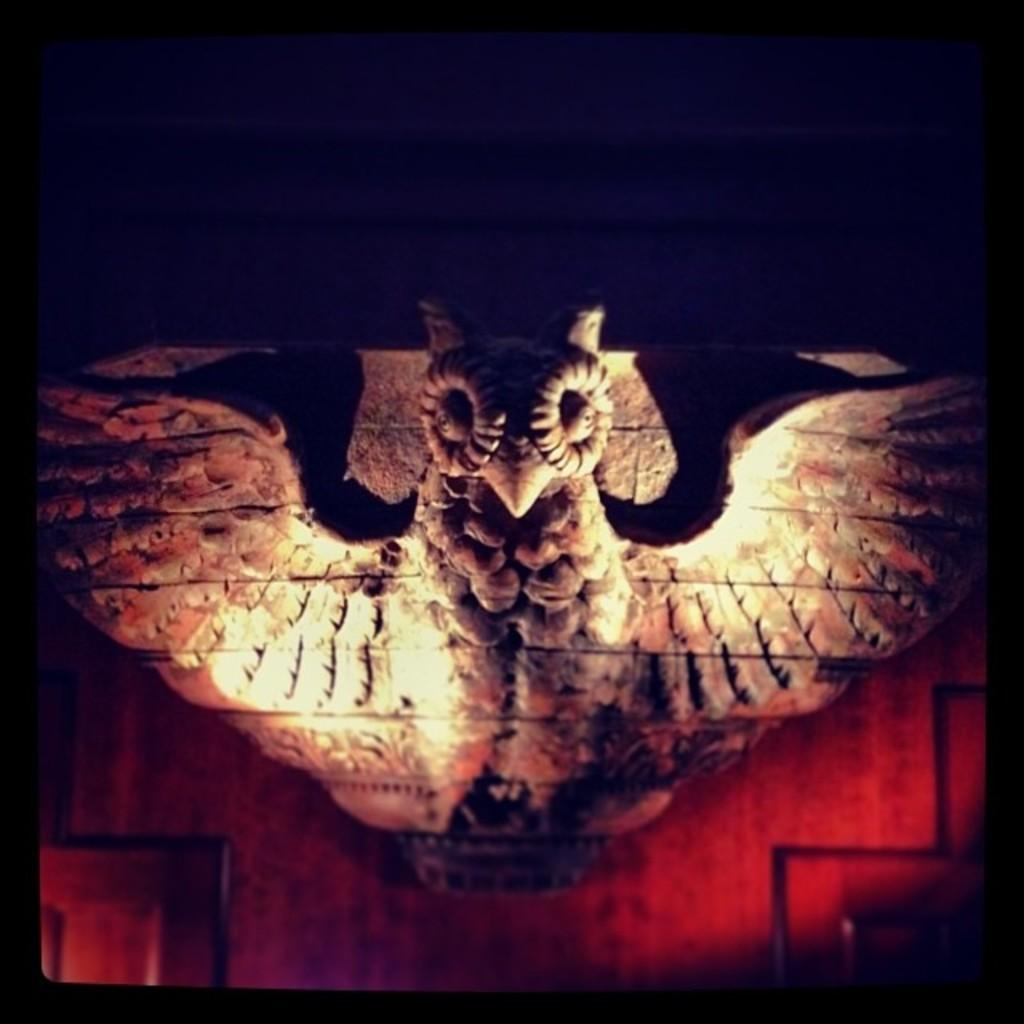What is on the wall in the image? There is a sculpture on the wall in the image. What else can be seen in the image besides the sculpture? There are objects in the image. How would you describe the overall appearance of the image? The background of the image is dark. How much does the patch weigh in the image? There is no patch present in the image, so it is not possible to determine its weight. 